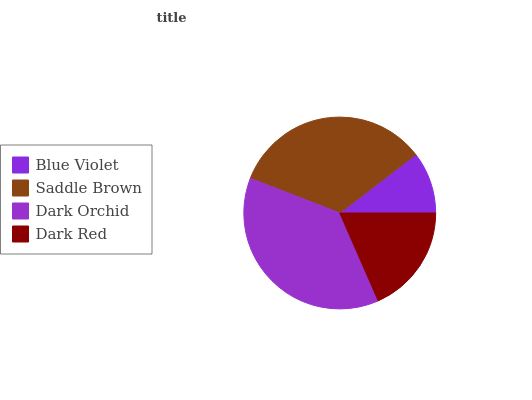Is Blue Violet the minimum?
Answer yes or no. Yes. Is Dark Orchid the maximum?
Answer yes or no. Yes. Is Saddle Brown the minimum?
Answer yes or no. No. Is Saddle Brown the maximum?
Answer yes or no. No. Is Saddle Brown greater than Blue Violet?
Answer yes or no. Yes. Is Blue Violet less than Saddle Brown?
Answer yes or no. Yes. Is Blue Violet greater than Saddle Brown?
Answer yes or no. No. Is Saddle Brown less than Blue Violet?
Answer yes or no. No. Is Saddle Brown the high median?
Answer yes or no. Yes. Is Dark Red the low median?
Answer yes or no. Yes. Is Dark Orchid the high median?
Answer yes or no. No. Is Saddle Brown the low median?
Answer yes or no. No. 